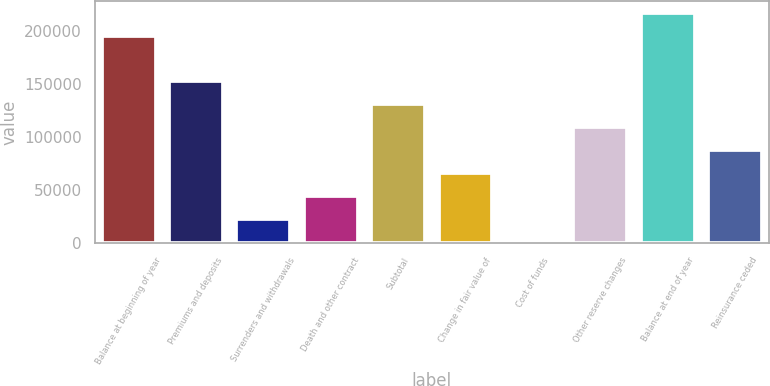Convert chart. <chart><loc_0><loc_0><loc_500><loc_500><bar_chart><fcel>Balance at beginning of year<fcel>Premiums and deposits<fcel>Surrenders and withdrawals<fcel>Death and other contract<fcel>Subtotal<fcel>Change in fair value of<fcel>Cost of funds<fcel>Other reserve changes<fcel>Balance at end of year<fcel>Reinsurance ceded<nl><fcel>196083<fcel>152599<fcel>22147<fcel>43889<fcel>130857<fcel>65631<fcel>405<fcel>109115<fcel>217825<fcel>87373<nl></chart> 